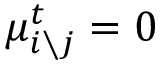Convert formula to latex. <formula><loc_0><loc_0><loc_500><loc_500>\mu _ { i \ j } ^ { t } = 0</formula> 